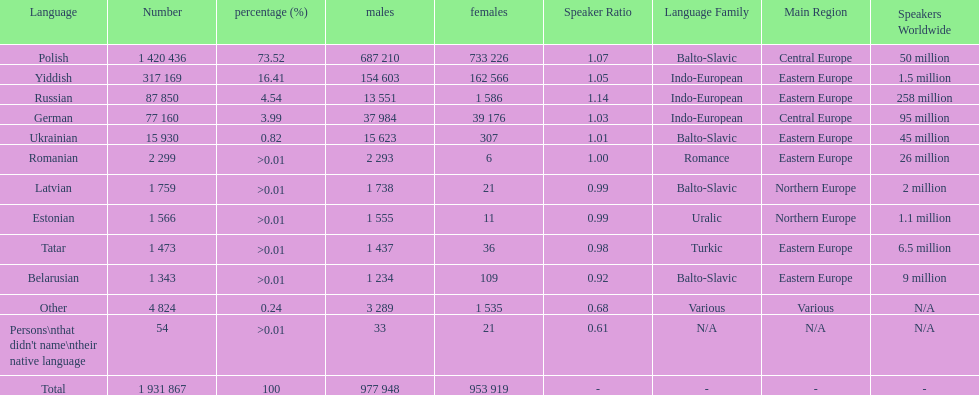What are all of the languages used in the warsaw governorate? Polish, Yiddish, Russian, German, Ukrainian, Romanian, Latvian, Estonian, Tatar, Belarusian, Other, Persons\nthat didn't name\ntheir native language. Which language was comprised of the least number of female speakers? Romanian. 